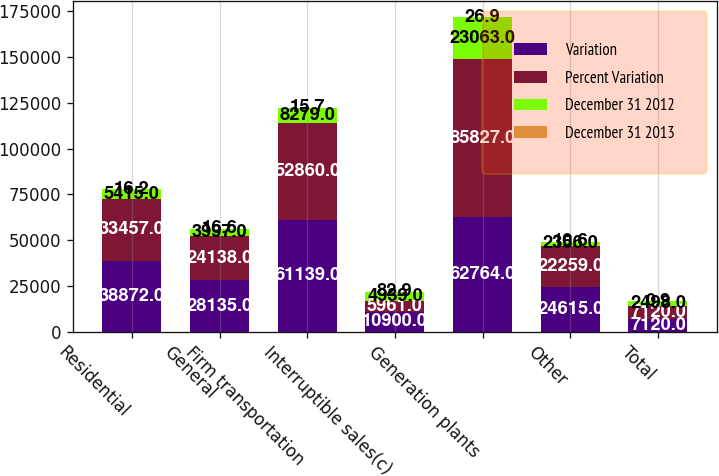Convert chart to OTSL. <chart><loc_0><loc_0><loc_500><loc_500><stacked_bar_chart><ecel><fcel>Residential<fcel>General<fcel>Firm transportation<fcel>Interruptible sales(c)<fcel>Generation plants<fcel>Other<fcel>Total<nl><fcel>Variation<fcel>38872<fcel>28135<fcel>61139<fcel>10900<fcel>62764<fcel>24615<fcel>7120<nl><fcel>Percent Variation<fcel>33457<fcel>24138<fcel>52860<fcel>5961<fcel>85827<fcel>22259<fcel>7120<nl><fcel>December 31 2012<fcel>5415<fcel>3997<fcel>8279<fcel>4939<fcel>23063<fcel>2356<fcel>2498<nl><fcel>December 31 2013<fcel>16.2<fcel>16.6<fcel>15.7<fcel>82.9<fcel>26.9<fcel>10.6<fcel>0.9<nl></chart> 